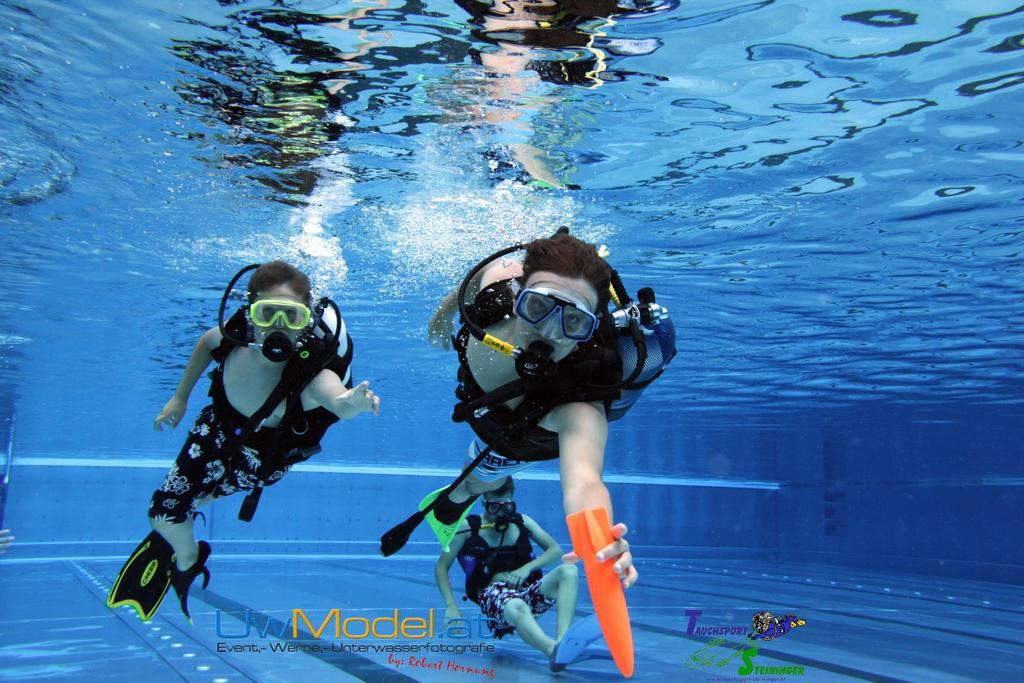How many people are in the water in the image? There are three persons in the water in the image. What are the people wearing while in the water? The persons are wearing spectacles. What additional equipment is present in the image? There is an oxygen cylinder present. What is covering the noses of the people in the image? The persons have masks covering their noses. What type of chalk is being used by the dad in the image? There is no dad or chalk present in the image. What system is being used to provide oxygen to the people in the image? The image does not show a specific system for providing oxygen; it only shows an oxygen cylinder. 